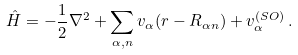Convert formula to latex. <formula><loc_0><loc_0><loc_500><loc_500>\hat { H } = - \frac { 1 } { 2 } \nabla ^ { 2 } + \sum _ { \alpha , n } v _ { \alpha } ( { r } - { R } _ { \alpha n } ) + v _ { \alpha } ^ { ( S O ) } \, .</formula> 